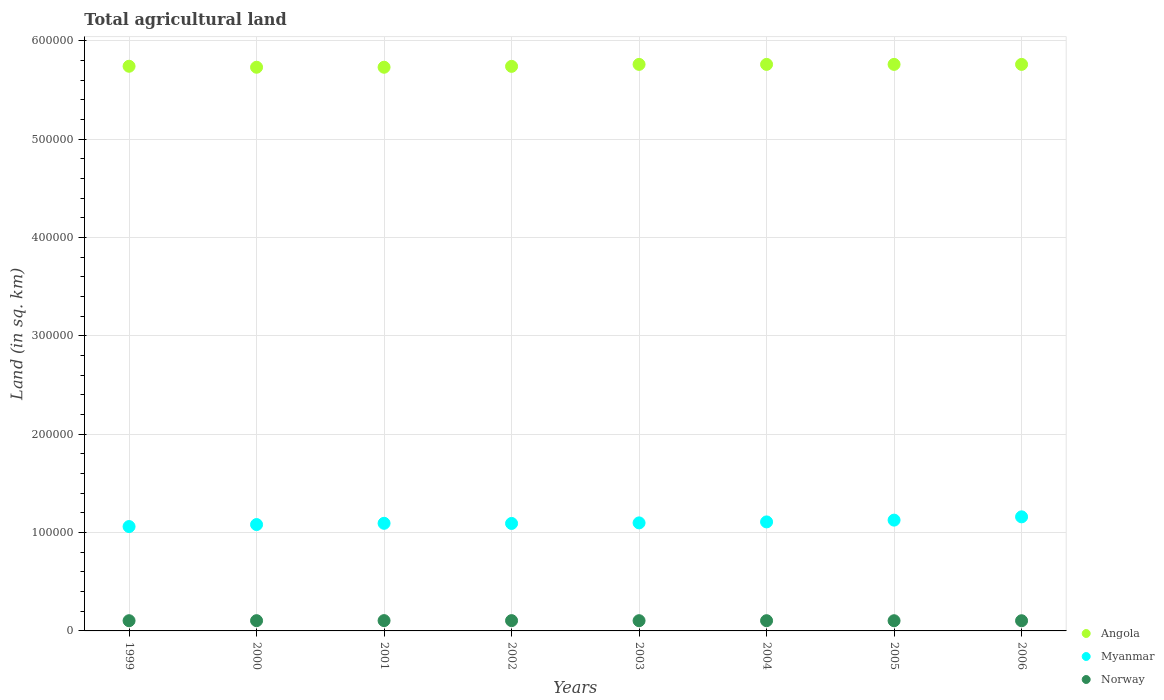Is the number of dotlines equal to the number of legend labels?
Your response must be concise. Yes. What is the total agricultural land in Norway in 1999?
Make the answer very short. 1.04e+04. Across all years, what is the maximum total agricultural land in Norway?
Your answer should be compact. 1.05e+04. Across all years, what is the minimum total agricultural land in Myanmar?
Your response must be concise. 1.06e+05. What is the total total agricultural land in Angola in the graph?
Your response must be concise. 4.60e+06. What is the difference between the total agricultural land in Myanmar in 2001 and that in 2003?
Your answer should be compact. -430. What is the difference between the total agricultural land in Norway in 1999 and the total agricultural land in Myanmar in 2005?
Give a very brief answer. -1.02e+05. What is the average total agricultural land in Norway per year?
Ensure brevity in your answer.  1.04e+04. In the year 2006, what is the difference between the total agricultural land in Myanmar and total agricultural land in Angola?
Make the answer very short. -4.60e+05. What is the ratio of the total agricultural land in Norway in 2003 to that in 2005?
Make the answer very short. 1. Is the difference between the total agricultural land in Myanmar in 2001 and 2005 greater than the difference between the total agricultural land in Angola in 2001 and 2005?
Give a very brief answer. No. What is the difference between the highest and the second highest total agricultural land in Myanmar?
Your answer should be very brief. 3340. What is the difference between the highest and the lowest total agricultural land in Angola?
Provide a succinct answer. 2900. In how many years, is the total agricultural land in Myanmar greater than the average total agricultural land in Myanmar taken over all years?
Make the answer very short. 3. Is the sum of the total agricultural land in Myanmar in 2000 and 2001 greater than the maximum total agricultural land in Angola across all years?
Give a very brief answer. No. Is it the case that in every year, the sum of the total agricultural land in Norway and total agricultural land in Angola  is greater than the total agricultural land in Myanmar?
Offer a very short reply. Yes. Is the total agricultural land in Myanmar strictly greater than the total agricultural land in Angola over the years?
Provide a succinct answer. No. What is the difference between two consecutive major ticks on the Y-axis?
Offer a very short reply. 1.00e+05. Where does the legend appear in the graph?
Make the answer very short. Bottom right. How many legend labels are there?
Provide a succinct answer. 3. How are the legend labels stacked?
Your response must be concise. Vertical. What is the title of the graph?
Offer a terse response. Total agricultural land. Does "Guinea" appear as one of the legend labels in the graph?
Offer a terse response. No. What is the label or title of the Y-axis?
Ensure brevity in your answer.  Land (in sq. km). What is the Land (in sq. km) in Angola in 1999?
Your answer should be compact. 5.74e+05. What is the Land (in sq. km) in Myanmar in 1999?
Offer a terse response. 1.06e+05. What is the Land (in sq. km) of Norway in 1999?
Make the answer very short. 1.04e+04. What is the Land (in sq. km) of Angola in 2000?
Offer a terse response. 5.73e+05. What is the Land (in sq. km) of Myanmar in 2000?
Ensure brevity in your answer.  1.08e+05. What is the Land (in sq. km) of Norway in 2000?
Make the answer very short. 1.04e+04. What is the Land (in sq. km) in Angola in 2001?
Offer a terse response. 5.73e+05. What is the Land (in sq. km) of Myanmar in 2001?
Offer a very short reply. 1.09e+05. What is the Land (in sq. km) of Norway in 2001?
Make the answer very short. 1.05e+04. What is the Land (in sq. km) in Angola in 2002?
Provide a succinct answer. 5.74e+05. What is the Land (in sq. km) in Myanmar in 2002?
Your response must be concise. 1.09e+05. What is the Land (in sq. km) of Norway in 2002?
Your answer should be very brief. 1.05e+04. What is the Land (in sq. km) of Angola in 2003?
Provide a short and direct response. 5.76e+05. What is the Land (in sq. km) in Myanmar in 2003?
Make the answer very short. 1.10e+05. What is the Land (in sq. km) of Norway in 2003?
Your response must be concise. 1.04e+04. What is the Land (in sq. km) of Angola in 2004?
Offer a very short reply. 5.76e+05. What is the Land (in sq. km) of Myanmar in 2004?
Keep it short and to the point. 1.11e+05. What is the Land (in sq. km) in Norway in 2004?
Offer a terse response. 1.04e+04. What is the Land (in sq. km) in Angola in 2005?
Keep it short and to the point. 5.76e+05. What is the Land (in sq. km) of Myanmar in 2005?
Your answer should be compact. 1.13e+05. What is the Land (in sq. km) of Norway in 2005?
Your answer should be very brief. 1.04e+04. What is the Land (in sq. km) in Angola in 2006?
Offer a terse response. 5.76e+05. What is the Land (in sq. km) of Myanmar in 2006?
Provide a succinct answer. 1.16e+05. What is the Land (in sq. km) of Norway in 2006?
Your answer should be compact. 1.04e+04. Across all years, what is the maximum Land (in sq. km) in Angola?
Offer a very short reply. 5.76e+05. Across all years, what is the maximum Land (in sq. km) of Myanmar?
Make the answer very short. 1.16e+05. Across all years, what is the maximum Land (in sq. km) of Norway?
Offer a terse response. 1.05e+04. Across all years, what is the minimum Land (in sq. km) in Angola?
Make the answer very short. 5.73e+05. Across all years, what is the minimum Land (in sq. km) of Myanmar?
Ensure brevity in your answer.  1.06e+05. Across all years, what is the minimum Land (in sq. km) of Norway?
Provide a short and direct response. 1.04e+04. What is the total Land (in sq. km) in Angola in the graph?
Ensure brevity in your answer.  4.60e+06. What is the total Land (in sq. km) in Myanmar in the graph?
Give a very brief answer. 8.82e+05. What is the total Land (in sq. km) of Norway in the graph?
Provide a succinct answer. 8.32e+04. What is the difference between the Land (in sq. km) of Myanmar in 1999 and that in 2000?
Offer a very short reply. -2030. What is the difference between the Land (in sq. km) in Myanmar in 1999 and that in 2001?
Give a very brief answer. -3300. What is the difference between the Land (in sq. km) of Norway in 1999 and that in 2001?
Offer a terse response. -90. What is the difference between the Land (in sq. km) of Myanmar in 1999 and that in 2002?
Ensure brevity in your answer.  -3160. What is the difference between the Land (in sq. km) of Norway in 1999 and that in 2002?
Keep it short and to the point. -80. What is the difference between the Land (in sq. km) of Angola in 1999 and that in 2003?
Make the answer very short. -1900. What is the difference between the Land (in sq. km) in Myanmar in 1999 and that in 2003?
Give a very brief answer. -3730. What is the difference between the Land (in sq. km) of Angola in 1999 and that in 2004?
Keep it short and to the point. -1900. What is the difference between the Land (in sq. km) of Myanmar in 1999 and that in 2004?
Offer a very short reply. -4730. What is the difference between the Land (in sq. km) in Norway in 1999 and that in 2004?
Give a very brief answer. -20. What is the difference between the Land (in sq. km) of Angola in 1999 and that in 2005?
Offer a very short reply. -1900. What is the difference between the Land (in sq. km) in Myanmar in 1999 and that in 2005?
Provide a short and direct response. -6540. What is the difference between the Land (in sq. km) of Norway in 1999 and that in 2005?
Keep it short and to the point. 20. What is the difference between the Land (in sq. km) of Angola in 1999 and that in 2006?
Make the answer very short. -1900. What is the difference between the Land (in sq. km) in Myanmar in 1999 and that in 2006?
Your answer should be very brief. -9880. What is the difference between the Land (in sq. km) in Angola in 2000 and that in 2001?
Your response must be concise. 0. What is the difference between the Land (in sq. km) of Myanmar in 2000 and that in 2001?
Your answer should be compact. -1270. What is the difference between the Land (in sq. km) of Norway in 2000 and that in 2001?
Your response must be concise. -50. What is the difference between the Land (in sq. km) in Angola in 2000 and that in 2002?
Offer a very short reply. -900. What is the difference between the Land (in sq. km) in Myanmar in 2000 and that in 2002?
Ensure brevity in your answer.  -1130. What is the difference between the Land (in sq. km) in Norway in 2000 and that in 2002?
Ensure brevity in your answer.  -40. What is the difference between the Land (in sq. km) in Angola in 2000 and that in 2003?
Your response must be concise. -2900. What is the difference between the Land (in sq. km) in Myanmar in 2000 and that in 2003?
Make the answer very short. -1700. What is the difference between the Land (in sq. km) in Angola in 2000 and that in 2004?
Provide a short and direct response. -2900. What is the difference between the Land (in sq. km) in Myanmar in 2000 and that in 2004?
Ensure brevity in your answer.  -2700. What is the difference between the Land (in sq. km) in Angola in 2000 and that in 2005?
Provide a succinct answer. -2900. What is the difference between the Land (in sq. km) of Myanmar in 2000 and that in 2005?
Give a very brief answer. -4510. What is the difference between the Land (in sq. km) in Norway in 2000 and that in 2005?
Your response must be concise. 60. What is the difference between the Land (in sq. km) in Angola in 2000 and that in 2006?
Your answer should be compact. -2900. What is the difference between the Land (in sq. km) of Myanmar in 2000 and that in 2006?
Your response must be concise. -7850. What is the difference between the Land (in sq. km) in Angola in 2001 and that in 2002?
Provide a succinct answer. -900. What is the difference between the Land (in sq. km) of Myanmar in 2001 and that in 2002?
Offer a terse response. 140. What is the difference between the Land (in sq. km) in Norway in 2001 and that in 2002?
Your answer should be very brief. 10. What is the difference between the Land (in sq. km) of Angola in 2001 and that in 2003?
Make the answer very short. -2900. What is the difference between the Land (in sq. km) of Myanmar in 2001 and that in 2003?
Ensure brevity in your answer.  -430. What is the difference between the Land (in sq. km) of Norway in 2001 and that in 2003?
Keep it short and to the point. 70. What is the difference between the Land (in sq. km) in Angola in 2001 and that in 2004?
Ensure brevity in your answer.  -2900. What is the difference between the Land (in sq. km) in Myanmar in 2001 and that in 2004?
Your answer should be very brief. -1430. What is the difference between the Land (in sq. km) of Norway in 2001 and that in 2004?
Provide a succinct answer. 70. What is the difference between the Land (in sq. km) in Angola in 2001 and that in 2005?
Offer a very short reply. -2900. What is the difference between the Land (in sq. km) in Myanmar in 2001 and that in 2005?
Keep it short and to the point. -3240. What is the difference between the Land (in sq. km) in Norway in 2001 and that in 2005?
Offer a very short reply. 110. What is the difference between the Land (in sq. km) in Angola in 2001 and that in 2006?
Give a very brief answer. -2900. What is the difference between the Land (in sq. km) of Myanmar in 2001 and that in 2006?
Keep it short and to the point. -6580. What is the difference between the Land (in sq. km) in Norway in 2001 and that in 2006?
Your response must be concise. 120. What is the difference between the Land (in sq. km) of Angola in 2002 and that in 2003?
Give a very brief answer. -2000. What is the difference between the Land (in sq. km) of Myanmar in 2002 and that in 2003?
Offer a very short reply. -570. What is the difference between the Land (in sq. km) of Norway in 2002 and that in 2003?
Keep it short and to the point. 60. What is the difference between the Land (in sq. km) in Angola in 2002 and that in 2004?
Ensure brevity in your answer.  -2000. What is the difference between the Land (in sq. km) in Myanmar in 2002 and that in 2004?
Offer a very short reply. -1570. What is the difference between the Land (in sq. km) in Angola in 2002 and that in 2005?
Your answer should be very brief. -2000. What is the difference between the Land (in sq. km) in Myanmar in 2002 and that in 2005?
Provide a short and direct response. -3380. What is the difference between the Land (in sq. km) in Angola in 2002 and that in 2006?
Your answer should be compact. -2000. What is the difference between the Land (in sq. km) of Myanmar in 2002 and that in 2006?
Your response must be concise. -6720. What is the difference between the Land (in sq. km) of Norway in 2002 and that in 2006?
Keep it short and to the point. 110. What is the difference between the Land (in sq. km) in Angola in 2003 and that in 2004?
Provide a short and direct response. 0. What is the difference between the Land (in sq. km) in Myanmar in 2003 and that in 2004?
Your response must be concise. -1000. What is the difference between the Land (in sq. km) of Myanmar in 2003 and that in 2005?
Keep it short and to the point. -2810. What is the difference between the Land (in sq. km) of Norway in 2003 and that in 2005?
Your answer should be very brief. 40. What is the difference between the Land (in sq. km) in Myanmar in 2003 and that in 2006?
Your response must be concise. -6150. What is the difference between the Land (in sq. km) of Norway in 2003 and that in 2006?
Ensure brevity in your answer.  50. What is the difference between the Land (in sq. km) of Angola in 2004 and that in 2005?
Provide a short and direct response. 0. What is the difference between the Land (in sq. km) of Myanmar in 2004 and that in 2005?
Provide a short and direct response. -1810. What is the difference between the Land (in sq. km) in Angola in 2004 and that in 2006?
Your response must be concise. 0. What is the difference between the Land (in sq. km) in Myanmar in 2004 and that in 2006?
Offer a terse response. -5150. What is the difference between the Land (in sq. km) in Norway in 2004 and that in 2006?
Make the answer very short. 50. What is the difference between the Land (in sq. km) in Myanmar in 2005 and that in 2006?
Your response must be concise. -3340. What is the difference between the Land (in sq. km) in Angola in 1999 and the Land (in sq. km) in Myanmar in 2000?
Provide a short and direct response. 4.66e+05. What is the difference between the Land (in sq. km) in Angola in 1999 and the Land (in sq. km) in Norway in 2000?
Your answer should be compact. 5.64e+05. What is the difference between the Land (in sq. km) of Myanmar in 1999 and the Land (in sq. km) of Norway in 2000?
Make the answer very short. 9.57e+04. What is the difference between the Land (in sq. km) of Angola in 1999 and the Land (in sq. km) of Myanmar in 2001?
Offer a terse response. 4.65e+05. What is the difference between the Land (in sq. km) of Angola in 1999 and the Land (in sq. km) of Norway in 2001?
Make the answer very short. 5.64e+05. What is the difference between the Land (in sq. km) of Myanmar in 1999 and the Land (in sq. km) of Norway in 2001?
Ensure brevity in your answer.  9.56e+04. What is the difference between the Land (in sq. km) in Angola in 1999 and the Land (in sq. km) in Myanmar in 2002?
Offer a terse response. 4.65e+05. What is the difference between the Land (in sq. km) of Angola in 1999 and the Land (in sq. km) of Norway in 2002?
Your answer should be very brief. 5.64e+05. What is the difference between the Land (in sq. km) of Myanmar in 1999 and the Land (in sq. km) of Norway in 2002?
Your response must be concise. 9.56e+04. What is the difference between the Land (in sq. km) of Angola in 1999 and the Land (in sq. km) of Myanmar in 2003?
Ensure brevity in your answer.  4.64e+05. What is the difference between the Land (in sq. km) of Angola in 1999 and the Land (in sq. km) of Norway in 2003?
Offer a very short reply. 5.64e+05. What is the difference between the Land (in sq. km) in Myanmar in 1999 and the Land (in sq. km) in Norway in 2003?
Your answer should be very brief. 9.57e+04. What is the difference between the Land (in sq. km) of Angola in 1999 and the Land (in sq. km) of Myanmar in 2004?
Keep it short and to the point. 4.63e+05. What is the difference between the Land (in sq. km) of Angola in 1999 and the Land (in sq. km) of Norway in 2004?
Offer a terse response. 5.64e+05. What is the difference between the Land (in sq. km) of Myanmar in 1999 and the Land (in sq. km) of Norway in 2004?
Offer a terse response. 9.57e+04. What is the difference between the Land (in sq. km) of Angola in 1999 and the Land (in sq. km) of Myanmar in 2005?
Make the answer very short. 4.61e+05. What is the difference between the Land (in sq. km) in Angola in 1999 and the Land (in sq. km) in Norway in 2005?
Keep it short and to the point. 5.64e+05. What is the difference between the Land (in sq. km) in Myanmar in 1999 and the Land (in sq. km) in Norway in 2005?
Give a very brief answer. 9.57e+04. What is the difference between the Land (in sq. km) of Angola in 1999 and the Land (in sq. km) of Myanmar in 2006?
Make the answer very short. 4.58e+05. What is the difference between the Land (in sq. km) of Angola in 1999 and the Land (in sq. km) of Norway in 2006?
Keep it short and to the point. 5.64e+05. What is the difference between the Land (in sq. km) in Myanmar in 1999 and the Land (in sq. km) in Norway in 2006?
Offer a very short reply. 9.57e+04. What is the difference between the Land (in sq. km) of Angola in 2000 and the Land (in sq. km) of Myanmar in 2001?
Your answer should be very brief. 4.64e+05. What is the difference between the Land (in sq. km) of Angola in 2000 and the Land (in sq. km) of Norway in 2001?
Keep it short and to the point. 5.63e+05. What is the difference between the Land (in sq. km) of Myanmar in 2000 and the Land (in sq. km) of Norway in 2001?
Give a very brief answer. 9.76e+04. What is the difference between the Land (in sq. km) of Angola in 2000 and the Land (in sq. km) of Myanmar in 2002?
Ensure brevity in your answer.  4.64e+05. What is the difference between the Land (in sq. km) of Angola in 2000 and the Land (in sq. km) of Norway in 2002?
Provide a short and direct response. 5.63e+05. What is the difference between the Land (in sq. km) of Myanmar in 2000 and the Land (in sq. km) of Norway in 2002?
Provide a short and direct response. 9.77e+04. What is the difference between the Land (in sq. km) in Angola in 2000 and the Land (in sq. km) in Myanmar in 2003?
Ensure brevity in your answer.  4.63e+05. What is the difference between the Land (in sq. km) in Angola in 2000 and the Land (in sq. km) in Norway in 2003?
Offer a very short reply. 5.63e+05. What is the difference between the Land (in sq. km) of Myanmar in 2000 and the Land (in sq. km) of Norway in 2003?
Your answer should be compact. 9.77e+04. What is the difference between the Land (in sq. km) in Angola in 2000 and the Land (in sq. km) in Myanmar in 2004?
Offer a very short reply. 4.62e+05. What is the difference between the Land (in sq. km) of Angola in 2000 and the Land (in sq. km) of Norway in 2004?
Offer a terse response. 5.63e+05. What is the difference between the Land (in sq. km) of Myanmar in 2000 and the Land (in sq. km) of Norway in 2004?
Offer a very short reply. 9.77e+04. What is the difference between the Land (in sq. km) in Angola in 2000 and the Land (in sq. km) in Myanmar in 2005?
Ensure brevity in your answer.  4.60e+05. What is the difference between the Land (in sq. km) of Angola in 2000 and the Land (in sq. km) of Norway in 2005?
Your answer should be very brief. 5.63e+05. What is the difference between the Land (in sq. km) in Myanmar in 2000 and the Land (in sq. km) in Norway in 2005?
Your answer should be very brief. 9.78e+04. What is the difference between the Land (in sq. km) in Angola in 2000 and the Land (in sq. km) in Myanmar in 2006?
Give a very brief answer. 4.57e+05. What is the difference between the Land (in sq. km) in Angola in 2000 and the Land (in sq. km) in Norway in 2006?
Your response must be concise. 5.63e+05. What is the difference between the Land (in sq. km) in Myanmar in 2000 and the Land (in sq. km) in Norway in 2006?
Offer a terse response. 9.78e+04. What is the difference between the Land (in sq. km) in Angola in 2001 and the Land (in sq. km) in Myanmar in 2002?
Offer a terse response. 4.64e+05. What is the difference between the Land (in sq. km) of Angola in 2001 and the Land (in sq. km) of Norway in 2002?
Keep it short and to the point. 5.63e+05. What is the difference between the Land (in sq. km) in Myanmar in 2001 and the Land (in sq. km) in Norway in 2002?
Provide a succinct answer. 9.89e+04. What is the difference between the Land (in sq. km) of Angola in 2001 and the Land (in sq. km) of Myanmar in 2003?
Your response must be concise. 4.63e+05. What is the difference between the Land (in sq. km) in Angola in 2001 and the Land (in sq. km) in Norway in 2003?
Offer a very short reply. 5.63e+05. What is the difference between the Land (in sq. km) in Myanmar in 2001 and the Land (in sq. km) in Norway in 2003?
Offer a terse response. 9.90e+04. What is the difference between the Land (in sq. km) of Angola in 2001 and the Land (in sq. km) of Myanmar in 2004?
Your answer should be very brief. 4.62e+05. What is the difference between the Land (in sq. km) of Angola in 2001 and the Land (in sq. km) of Norway in 2004?
Ensure brevity in your answer.  5.63e+05. What is the difference between the Land (in sq. km) in Myanmar in 2001 and the Land (in sq. km) in Norway in 2004?
Provide a short and direct response. 9.90e+04. What is the difference between the Land (in sq. km) of Angola in 2001 and the Land (in sq. km) of Myanmar in 2005?
Your answer should be very brief. 4.60e+05. What is the difference between the Land (in sq. km) of Angola in 2001 and the Land (in sq. km) of Norway in 2005?
Provide a short and direct response. 5.63e+05. What is the difference between the Land (in sq. km) in Myanmar in 2001 and the Land (in sq. km) in Norway in 2005?
Your response must be concise. 9.90e+04. What is the difference between the Land (in sq. km) in Angola in 2001 and the Land (in sq. km) in Myanmar in 2006?
Make the answer very short. 4.57e+05. What is the difference between the Land (in sq. km) of Angola in 2001 and the Land (in sq. km) of Norway in 2006?
Your answer should be compact. 5.63e+05. What is the difference between the Land (in sq. km) in Myanmar in 2001 and the Land (in sq. km) in Norway in 2006?
Make the answer very short. 9.90e+04. What is the difference between the Land (in sq. km) in Angola in 2002 and the Land (in sq. km) in Myanmar in 2003?
Keep it short and to the point. 4.64e+05. What is the difference between the Land (in sq. km) in Angola in 2002 and the Land (in sq. km) in Norway in 2003?
Make the answer very short. 5.64e+05. What is the difference between the Land (in sq. km) in Myanmar in 2002 and the Land (in sq. km) in Norway in 2003?
Your answer should be compact. 9.88e+04. What is the difference between the Land (in sq. km) in Angola in 2002 and the Land (in sq. km) in Myanmar in 2004?
Provide a short and direct response. 4.63e+05. What is the difference between the Land (in sq. km) of Angola in 2002 and the Land (in sq. km) of Norway in 2004?
Your answer should be very brief. 5.64e+05. What is the difference between the Land (in sq. km) of Myanmar in 2002 and the Land (in sq. km) of Norway in 2004?
Your response must be concise. 9.88e+04. What is the difference between the Land (in sq. km) in Angola in 2002 and the Land (in sq. km) in Myanmar in 2005?
Your response must be concise. 4.61e+05. What is the difference between the Land (in sq. km) in Angola in 2002 and the Land (in sq. km) in Norway in 2005?
Keep it short and to the point. 5.64e+05. What is the difference between the Land (in sq. km) of Myanmar in 2002 and the Land (in sq. km) of Norway in 2005?
Your response must be concise. 9.89e+04. What is the difference between the Land (in sq. km) of Angola in 2002 and the Land (in sq. km) of Myanmar in 2006?
Provide a short and direct response. 4.58e+05. What is the difference between the Land (in sq. km) in Angola in 2002 and the Land (in sq. km) in Norway in 2006?
Make the answer very short. 5.64e+05. What is the difference between the Land (in sq. km) in Myanmar in 2002 and the Land (in sq. km) in Norway in 2006?
Your answer should be very brief. 9.89e+04. What is the difference between the Land (in sq. km) of Angola in 2003 and the Land (in sq. km) of Myanmar in 2004?
Keep it short and to the point. 4.65e+05. What is the difference between the Land (in sq. km) in Angola in 2003 and the Land (in sq. km) in Norway in 2004?
Offer a very short reply. 5.66e+05. What is the difference between the Land (in sq. km) in Myanmar in 2003 and the Land (in sq. km) in Norway in 2004?
Keep it short and to the point. 9.94e+04. What is the difference between the Land (in sq. km) of Angola in 2003 and the Land (in sq. km) of Myanmar in 2005?
Your response must be concise. 4.63e+05. What is the difference between the Land (in sq. km) in Angola in 2003 and the Land (in sq. km) in Norway in 2005?
Give a very brief answer. 5.66e+05. What is the difference between the Land (in sq. km) in Myanmar in 2003 and the Land (in sq. km) in Norway in 2005?
Ensure brevity in your answer.  9.95e+04. What is the difference between the Land (in sq. km) in Angola in 2003 and the Land (in sq. km) in Myanmar in 2006?
Offer a terse response. 4.60e+05. What is the difference between the Land (in sq. km) in Angola in 2003 and the Land (in sq. km) in Norway in 2006?
Provide a succinct answer. 5.66e+05. What is the difference between the Land (in sq. km) in Myanmar in 2003 and the Land (in sq. km) in Norway in 2006?
Your answer should be very brief. 9.95e+04. What is the difference between the Land (in sq. km) of Angola in 2004 and the Land (in sq. km) of Myanmar in 2005?
Give a very brief answer. 4.63e+05. What is the difference between the Land (in sq. km) in Angola in 2004 and the Land (in sq. km) in Norway in 2005?
Give a very brief answer. 5.66e+05. What is the difference between the Land (in sq. km) of Myanmar in 2004 and the Land (in sq. km) of Norway in 2005?
Give a very brief answer. 1.00e+05. What is the difference between the Land (in sq. km) in Angola in 2004 and the Land (in sq. km) in Myanmar in 2006?
Your response must be concise. 4.60e+05. What is the difference between the Land (in sq. km) in Angola in 2004 and the Land (in sq. km) in Norway in 2006?
Your answer should be very brief. 5.66e+05. What is the difference between the Land (in sq. km) in Myanmar in 2004 and the Land (in sq. km) in Norway in 2006?
Keep it short and to the point. 1.00e+05. What is the difference between the Land (in sq. km) in Angola in 2005 and the Land (in sq. km) in Myanmar in 2006?
Offer a very short reply. 4.60e+05. What is the difference between the Land (in sq. km) of Angola in 2005 and the Land (in sq. km) of Norway in 2006?
Provide a short and direct response. 5.66e+05. What is the difference between the Land (in sq. km) in Myanmar in 2005 and the Land (in sq. km) in Norway in 2006?
Offer a very short reply. 1.02e+05. What is the average Land (in sq. km) in Angola per year?
Give a very brief answer. 5.75e+05. What is the average Land (in sq. km) in Myanmar per year?
Provide a short and direct response. 1.10e+05. What is the average Land (in sq. km) of Norway per year?
Give a very brief answer. 1.04e+04. In the year 1999, what is the difference between the Land (in sq. km) of Angola and Land (in sq. km) of Myanmar?
Ensure brevity in your answer.  4.68e+05. In the year 1999, what is the difference between the Land (in sq. km) of Angola and Land (in sq. km) of Norway?
Offer a terse response. 5.64e+05. In the year 1999, what is the difference between the Land (in sq. km) of Myanmar and Land (in sq. km) of Norway?
Ensure brevity in your answer.  9.57e+04. In the year 2000, what is the difference between the Land (in sq. km) in Angola and Land (in sq. km) in Myanmar?
Ensure brevity in your answer.  4.65e+05. In the year 2000, what is the difference between the Land (in sq. km) of Angola and Land (in sq. km) of Norway?
Your answer should be compact. 5.63e+05. In the year 2000, what is the difference between the Land (in sq. km) in Myanmar and Land (in sq. km) in Norway?
Provide a succinct answer. 9.77e+04. In the year 2001, what is the difference between the Land (in sq. km) in Angola and Land (in sq. km) in Myanmar?
Ensure brevity in your answer.  4.64e+05. In the year 2001, what is the difference between the Land (in sq. km) of Angola and Land (in sq. km) of Norway?
Your response must be concise. 5.63e+05. In the year 2001, what is the difference between the Land (in sq. km) of Myanmar and Land (in sq. km) of Norway?
Provide a succinct answer. 9.89e+04. In the year 2002, what is the difference between the Land (in sq. km) of Angola and Land (in sq. km) of Myanmar?
Keep it short and to the point. 4.65e+05. In the year 2002, what is the difference between the Land (in sq. km) in Angola and Land (in sq. km) in Norway?
Make the answer very short. 5.63e+05. In the year 2002, what is the difference between the Land (in sq. km) in Myanmar and Land (in sq. km) in Norway?
Give a very brief answer. 9.88e+04. In the year 2003, what is the difference between the Land (in sq. km) in Angola and Land (in sq. km) in Myanmar?
Your answer should be very brief. 4.66e+05. In the year 2003, what is the difference between the Land (in sq. km) in Angola and Land (in sq. km) in Norway?
Provide a short and direct response. 5.66e+05. In the year 2003, what is the difference between the Land (in sq. km) of Myanmar and Land (in sq. km) of Norway?
Your response must be concise. 9.94e+04. In the year 2004, what is the difference between the Land (in sq. km) in Angola and Land (in sq. km) in Myanmar?
Your response must be concise. 4.65e+05. In the year 2004, what is the difference between the Land (in sq. km) of Angola and Land (in sq. km) of Norway?
Offer a terse response. 5.66e+05. In the year 2004, what is the difference between the Land (in sq. km) of Myanmar and Land (in sq. km) of Norway?
Your answer should be very brief. 1.00e+05. In the year 2005, what is the difference between the Land (in sq. km) of Angola and Land (in sq. km) of Myanmar?
Provide a short and direct response. 4.63e+05. In the year 2005, what is the difference between the Land (in sq. km) of Angola and Land (in sq. km) of Norway?
Your answer should be very brief. 5.66e+05. In the year 2005, what is the difference between the Land (in sq. km) in Myanmar and Land (in sq. km) in Norway?
Give a very brief answer. 1.02e+05. In the year 2006, what is the difference between the Land (in sq. km) in Angola and Land (in sq. km) in Myanmar?
Offer a very short reply. 4.60e+05. In the year 2006, what is the difference between the Land (in sq. km) in Angola and Land (in sq. km) in Norway?
Offer a very short reply. 5.66e+05. In the year 2006, what is the difference between the Land (in sq. km) in Myanmar and Land (in sq. km) in Norway?
Offer a terse response. 1.06e+05. What is the ratio of the Land (in sq. km) of Myanmar in 1999 to that in 2000?
Keep it short and to the point. 0.98. What is the ratio of the Land (in sq. km) of Angola in 1999 to that in 2001?
Provide a short and direct response. 1. What is the ratio of the Land (in sq. km) of Myanmar in 1999 to that in 2001?
Provide a succinct answer. 0.97. What is the ratio of the Land (in sq. km) of Myanmar in 1999 to that in 2002?
Provide a succinct answer. 0.97. What is the ratio of the Land (in sq. km) in Myanmar in 1999 to that in 2004?
Ensure brevity in your answer.  0.96. What is the ratio of the Land (in sq. km) in Norway in 1999 to that in 2004?
Provide a succinct answer. 1. What is the ratio of the Land (in sq. km) in Myanmar in 1999 to that in 2005?
Your answer should be very brief. 0.94. What is the ratio of the Land (in sq. km) of Norway in 1999 to that in 2005?
Provide a succinct answer. 1. What is the ratio of the Land (in sq. km) of Myanmar in 1999 to that in 2006?
Ensure brevity in your answer.  0.91. What is the ratio of the Land (in sq. km) in Myanmar in 2000 to that in 2001?
Provide a succinct answer. 0.99. What is the ratio of the Land (in sq. km) in Angola in 2000 to that in 2003?
Provide a succinct answer. 0.99. What is the ratio of the Land (in sq. km) of Myanmar in 2000 to that in 2003?
Your answer should be compact. 0.98. What is the ratio of the Land (in sq. km) in Angola in 2000 to that in 2004?
Make the answer very short. 0.99. What is the ratio of the Land (in sq. km) of Myanmar in 2000 to that in 2004?
Make the answer very short. 0.98. What is the ratio of the Land (in sq. km) in Norway in 2000 to that in 2004?
Provide a succinct answer. 1. What is the ratio of the Land (in sq. km) of Angola in 2000 to that in 2005?
Keep it short and to the point. 0.99. What is the ratio of the Land (in sq. km) in Myanmar in 2000 to that in 2006?
Provide a succinct answer. 0.93. What is the ratio of the Land (in sq. km) in Norway in 2000 to that in 2006?
Offer a terse response. 1.01. What is the ratio of the Land (in sq. km) of Angola in 2001 to that in 2002?
Ensure brevity in your answer.  1. What is the ratio of the Land (in sq. km) in Myanmar in 2001 to that in 2002?
Offer a very short reply. 1. What is the ratio of the Land (in sq. km) in Myanmar in 2001 to that in 2003?
Provide a succinct answer. 1. What is the ratio of the Land (in sq. km) in Myanmar in 2001 to that in 2004?
Offer a very short reply. 0.99. What is the ratio of the Land (in sq. km) of Myanmar in 2001 to that in 2005?
Your response must be concise. 0.97. What is the ratio of the Land (in sq. km) in Norway in 2001 to that in 2005?
Provide a succinct answer. 1.01. What is the ratio of the Land (in sq. km) in Angola in 2001 to that in 2006?
Your response must be concise. 0.99. What is the ratio of the Land (in sq. km) of Myanmar in 2001 to that in 2006?
Provide a succinct answer. 0.94. What is the ratio of the Land (in sq. km) in Norway in 2001 to that in 2006?
Give a very brief answer. 1.01. What is the ratio of the Land (in sq. km) in Angola in 2002 to that in 2004?
Your answer should be very brief. 1. What is the ratio of the Land (in sq. km) of Myanmar in 2002 to that in 2004?
Provide a short and direct response. 0.99. What is the ratio of the Land (in sq. km) in Norway in 2002 to that in 2004?
Give a very brief answer. 1.01. What is the ratio of the Land (in sq. km) of Angola in 2002 to that in 2005?
Give a very brief answer. 1. What is the ratio of the Land (in sq. km) of Norway in 2002 to that in 2005?
Offer a terse response. 1.01. What is the ratio of the Land (in sq. km) in Myanmar in 2002 to that in 2006?
Your response must be concise. 0.94. What is the ratio of the Land (in sq. km) of Norway in 2002 to that in 2006?
Make the answer very short. 1.01. What is the ratio of the Land (in sq. km) of Angola in 2003 to that in 2004?
Give a very brief answer. 1. What is the ratio of the Land (in sq. km) of Myanmar in 2003 to that in 2004?
Ensure brevity in your answer.  0.99. What is the ratio of the Land (in sq. km) in Angola in 2003 to that in 2005?
Your response must be concise. 1. What is the ratio of the Land (in sq. km) in Myanmar in 2003 to that in 2005?
Your response must be concise. 0.98. What is the ratio of the Land (in sq. km) in Norway in 2003 to that in 2005?
Offer a very short reply. 1. What is the ratio of the Land (in sq. km) in Angola in 2003 to that in 2006?
Ensure brevity in your answer.  1. What is the ratio of the Land (in sq. km) in Myanmar in 2003 to that in 2006?
Provide a short and direct response. 0.95. What is the ratio of the Land (in sq. km) in Norway in 2003 to that in 2006?
Provide a short and direct response. 1. What is the ratio of the Land (in sq. km) of Myanmar in 2004 to that in 2005?
Provide a succinct answer. 0.98. What is the ratio of the Land (in sq. km) of Angola in 2004 to that in 2006?
Give a very brief answer. 1. What is the ratio of the Land (in sq. km) of Myanmar in 2004 to that in 2006?
Provide a succinct answer. 0.96. What is the ratio of the Land (in sq. km) of Norway in 2004 to that in 2006?
Offer a terse response. 1. What is the ratio of the Land (in sq. km) of Myanmar in 2005 to that in 2006?
Your answer should be compact. 0.97. What is the ratio of the Land (in sq. km) of Norway in 2005 to that in 2006?
Provide a succinct answer. 1. What is the difference between the highest and the second highest Land (in sq. km) in Myanmar?
Offer a very short reply. 3340. What is the difference between the highest and the lowest Land (in sq. km) of Angola?
Offer a very short reply. 2900. What is the difference between the highest and the lowest Land (in sq. km) of Myanmar?
Offer a terse response. 9880. What is the difference between the highest and the lowest Land (in sq. km) of Norway?
Offer a very short reply. 120. 